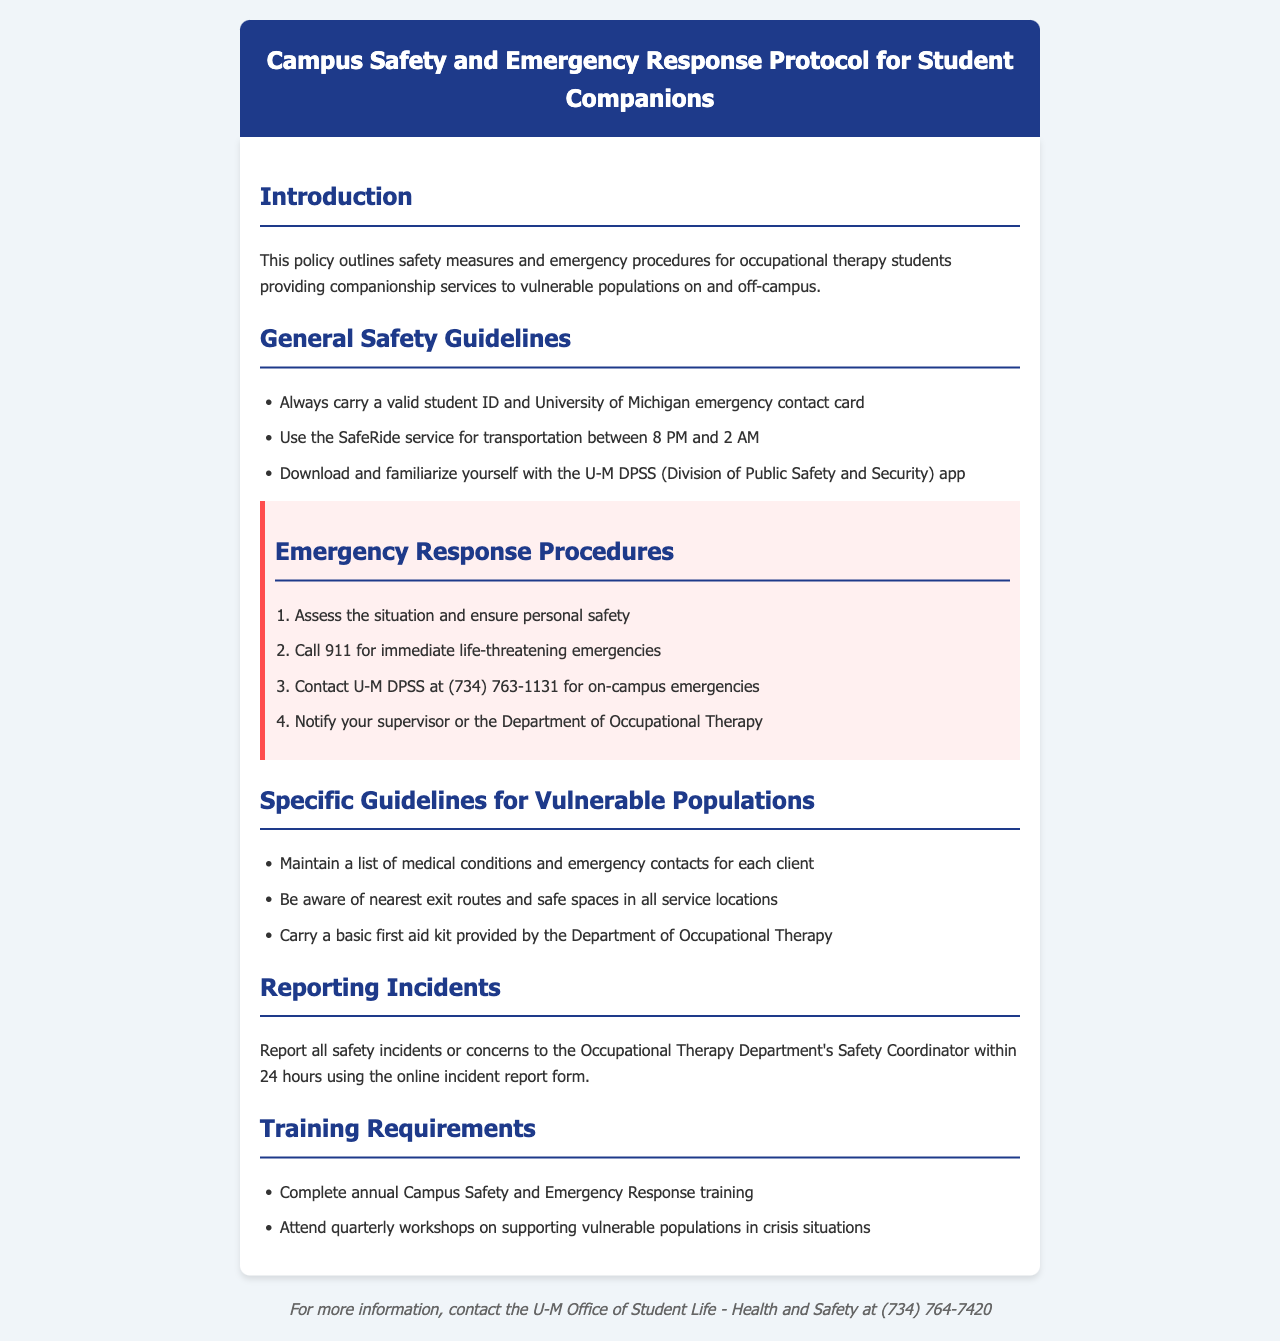What is the main focus of this policy? The main focus of the policy is to outline safety measures and emergency procedures for occupational therapy students providing companionship services to vulnerable populations.
Answer: safety measures and emergency procedures What time does the SafeRide service operate? The document specifies that the SafeRide service operates between 8 PM and 2 AM.
Answer: 8 PM to 2 AM What should you do in case of a life-threatening emergency? For a life-threatening emergency, you should call 911.
Answer: call 911 What should companions maintain for each client? Companions should maintain a list of medical conditions and emergency contacts for each client.
Answer: list of medical conditions and emergency contacts Who should be notified after an emergency? After an emergency, you should notify your supervisor or the Department of Occupational Therapy.
Answer: supervisor or the Department of Occupational Therapy How often must you complete safety training? The policy states that you must complete safety training annually.
Answer: annually What is the contact number for U-M DPSS? The U-M DPSS contact number provided in the document is (734) 763-1131.
Answer: (734) 763-1131 What is required to report safety incidents? You are required to report safety incidents using the online incident report form within 24 hours.
Answer: online incident report form within 24 hours What is included in the training requirements? Training requirements include completing annual Campus Safety and Emergency Response training and attending quarterly workshops.
Answer: annual training and quarterly workshops 